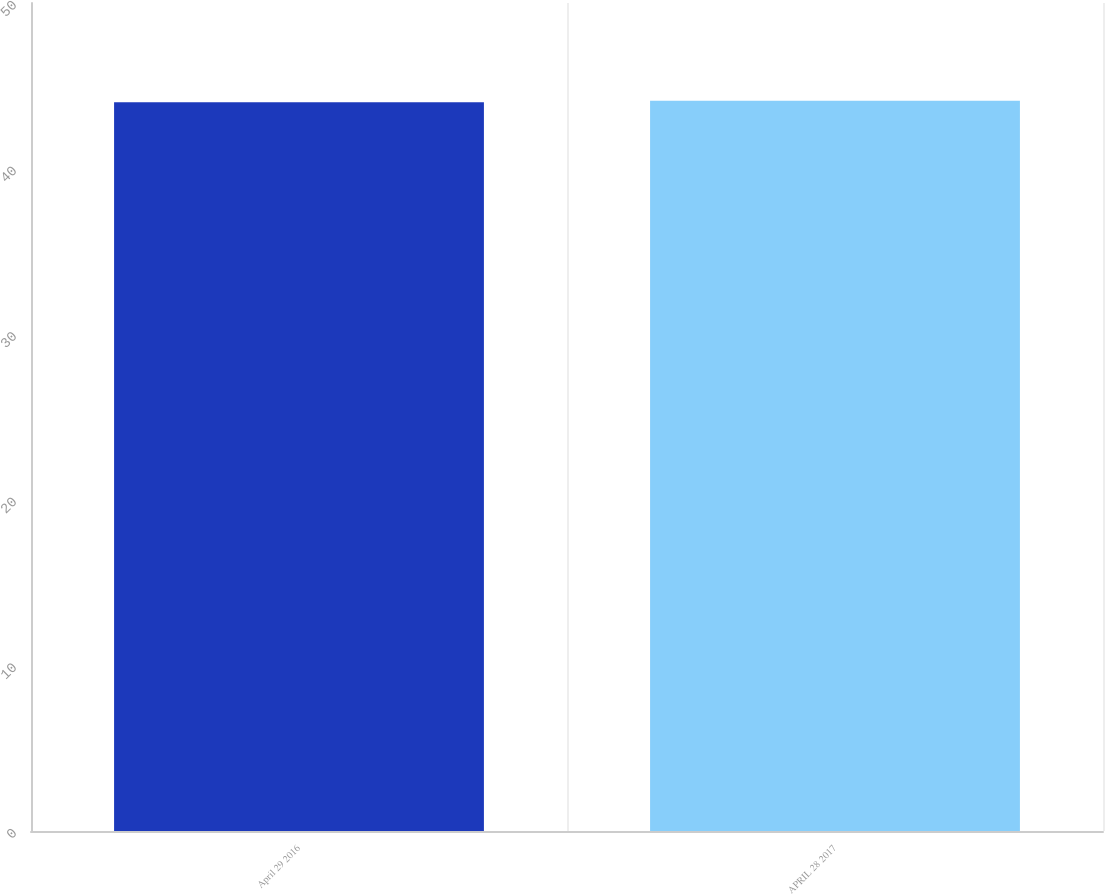Convert chart. <chart><loc_0><loc_0><loc_500><loc_500><bar_chart><fcel>April 29 2016<fcel>APRIL 28 2017<nl><fcel>44<fcel>44.1<nl></chart> 